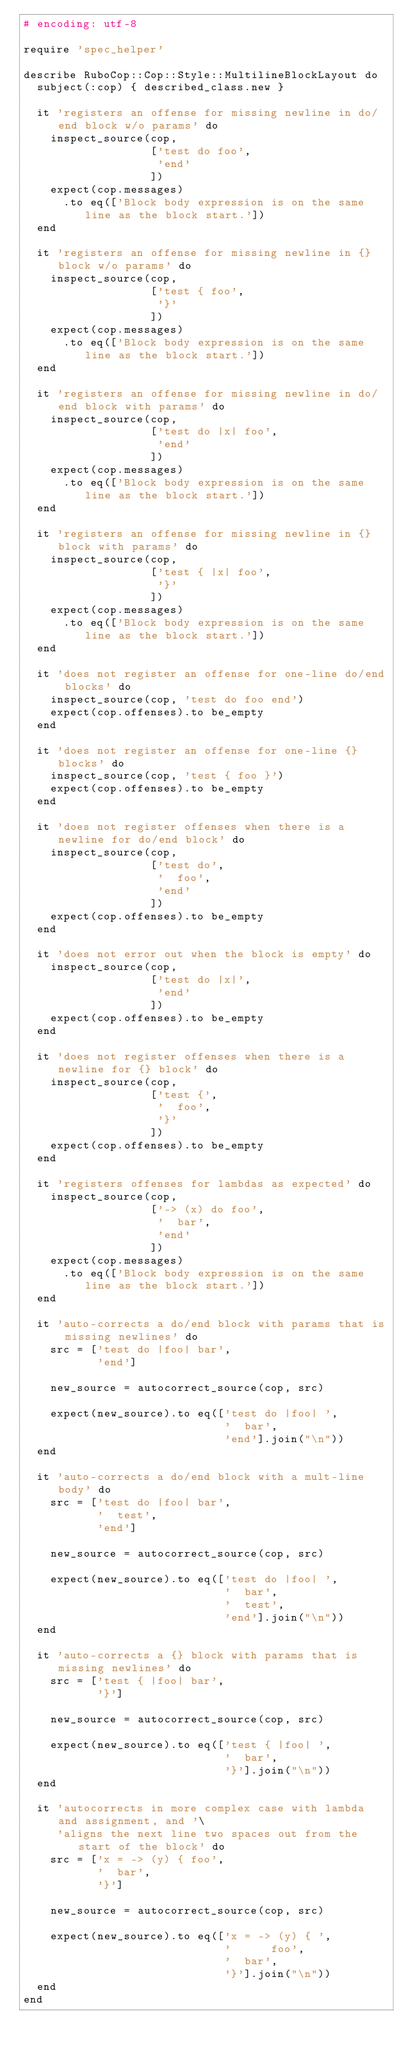<code> <loc_0><loc_0><loc_500><loc_500><_Ruby_># encoding: utf-8

require 'spec_helper'

describe RuboCop::Cop::Style::MultilineBlockLayout do
  subject(:cop) { described_class.new }

  it 'registers an offense for missing newline in do/end block w/o params' do
    inspect_source(cop,
                   ['test do foo',
                    'end'
                   ])
    expect(cop.messages)
      .to eq(['Block body expression is on the same line as the block start.'])
  end

  it 'registers an offense for missing newline in {} block w/o params' do
    inspect_source(cop,
                   ['test { foo',
                    '}'
                   ])
    expect(cop.messages)
      .to eq(['Block body expression is on the same line as the block start.'])
  end

  it 'registers an offense for missing newline in do/end block with params' do
    inspect_source(cop,
                   ['test do |x| foo',
                    'end'
                   ])
    expect(cop.messages)
      .to eq(['Block body expression is on the same line as the block start.'])
  end

  it 'registers an offense for missing newline in {} block with params' do
    inspect_source(cop,
                   ['test { |x| foo',
                    '}'
                   ])
    expect(cop.messages)
      .to eq(['Block body expression is on the same line as the block start.'])
  end

  it 'does not register an offense for one-line do/end blocks' do
    inspect_source(cop, 'test do foo end')
    expect(cop.offenses).to be_empty
  end

  it 'does not register an offense for one-line {} blocks' do
    inspect_source(cop, 'test { foo }')
    expect(cop.offenses).to be_empty
  end

  it 'does not register offenses when there is a newline for do/end block' do
    inspect_source(cop,
                   ['test do',
                    '  foo',
                    'end'
                   ])
    expect(cop.offenses).to be_empty
  end

  it 'does not error out when the block is empty' do
    inspect_source(cop,
                   ['test do |x|',
                    'end'
                   ])
    expect(cop.offenses).to be_empty
  end

  it 'does not register offenses when there is a newline for {} block' do
    inspect_source(cop,
                   ['test {',
                    '  foo',
                    '}'
                   ])
    expect(cop.offenses).to be_empty
  end

  it 'registers offenses for lambdas as expected' do
    inspect_source(cop,
                   ['-> (x) do foo',
                    '  bar',
                    'end'
                   ])
    expect(cop.messages)
      .to eq(['Block body expression is on the same line as the block start.'])
  end

  it 'auto-corrects a do/end block with params that is missing newlines' do
    src = ['test do |foo| bar',
           'end']

    new_source = autocorrect_source(cop, src)

    expect(new_source).to eq(['test do |foo| ',
                              '  bar',
                              'end'].join("\n"))
  end

  it 'auto-corrects a do/end block with a mult-line body' do
    src = ['test do |foo| bar',
           '  test',
           'end']

    new_source = autocorrect_source(cop, src)

    expect(new_source).to eq(['test do |foo| ',
                              '  bar',
                              '  test',
                              'end'].join("\n"))
  end

  it 'auto-corrects a {} block with params that is missing newlines' do
    src = ['test { |foo| bar',
           '}']

    new_source = autocorrect_source(cop, src)

    expect(new_source).to eq(['test { |foo| ',
                              '  bar',
                              '}'].join("\n"))
  end

  it 'autocorrects in more complex case with lambda and assignment, and '\
     'aligns the next line two spaces out from the start of the block' do
    src = ['x = -> (y) { foo',
           '  bar',
           '}']

    new_source = autocorrect_source(cop, src)

    expect(new_source).to eq(['x = -> (y) { ',
                              '      foo',
                              '  bar',
                              '}'].join("\n"))
  end
end
</code> 